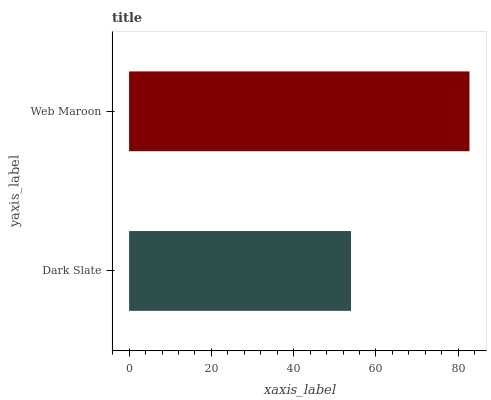Is Dark Slate the minimum?
Answer yes or no. Yes. Is Web Maroon the maximum?
Answer yes or no. Yes. Is Web Maroon the minimum?
Answer yes or no. No. Is Web Maroon greater than Dark Slate?
Answer yes or no. Yes. Is Dark Slate less than Web Maroon?
Answer yes or no. Yes. Is Dark Slate greater than Web Maroon?
Answer yes or no. No. Is Web Maroon less than Dark Slate?
Answer yes or no. No. Is Web Maroon the high median?
Answer yes or no. Yes. Is Dark Slate the low median?
Answer yes or no. Yes. Is Dark Slate the high median?
Answer yes or no. No. Is Web Maroon the low median?
Answer yes or no. No. 